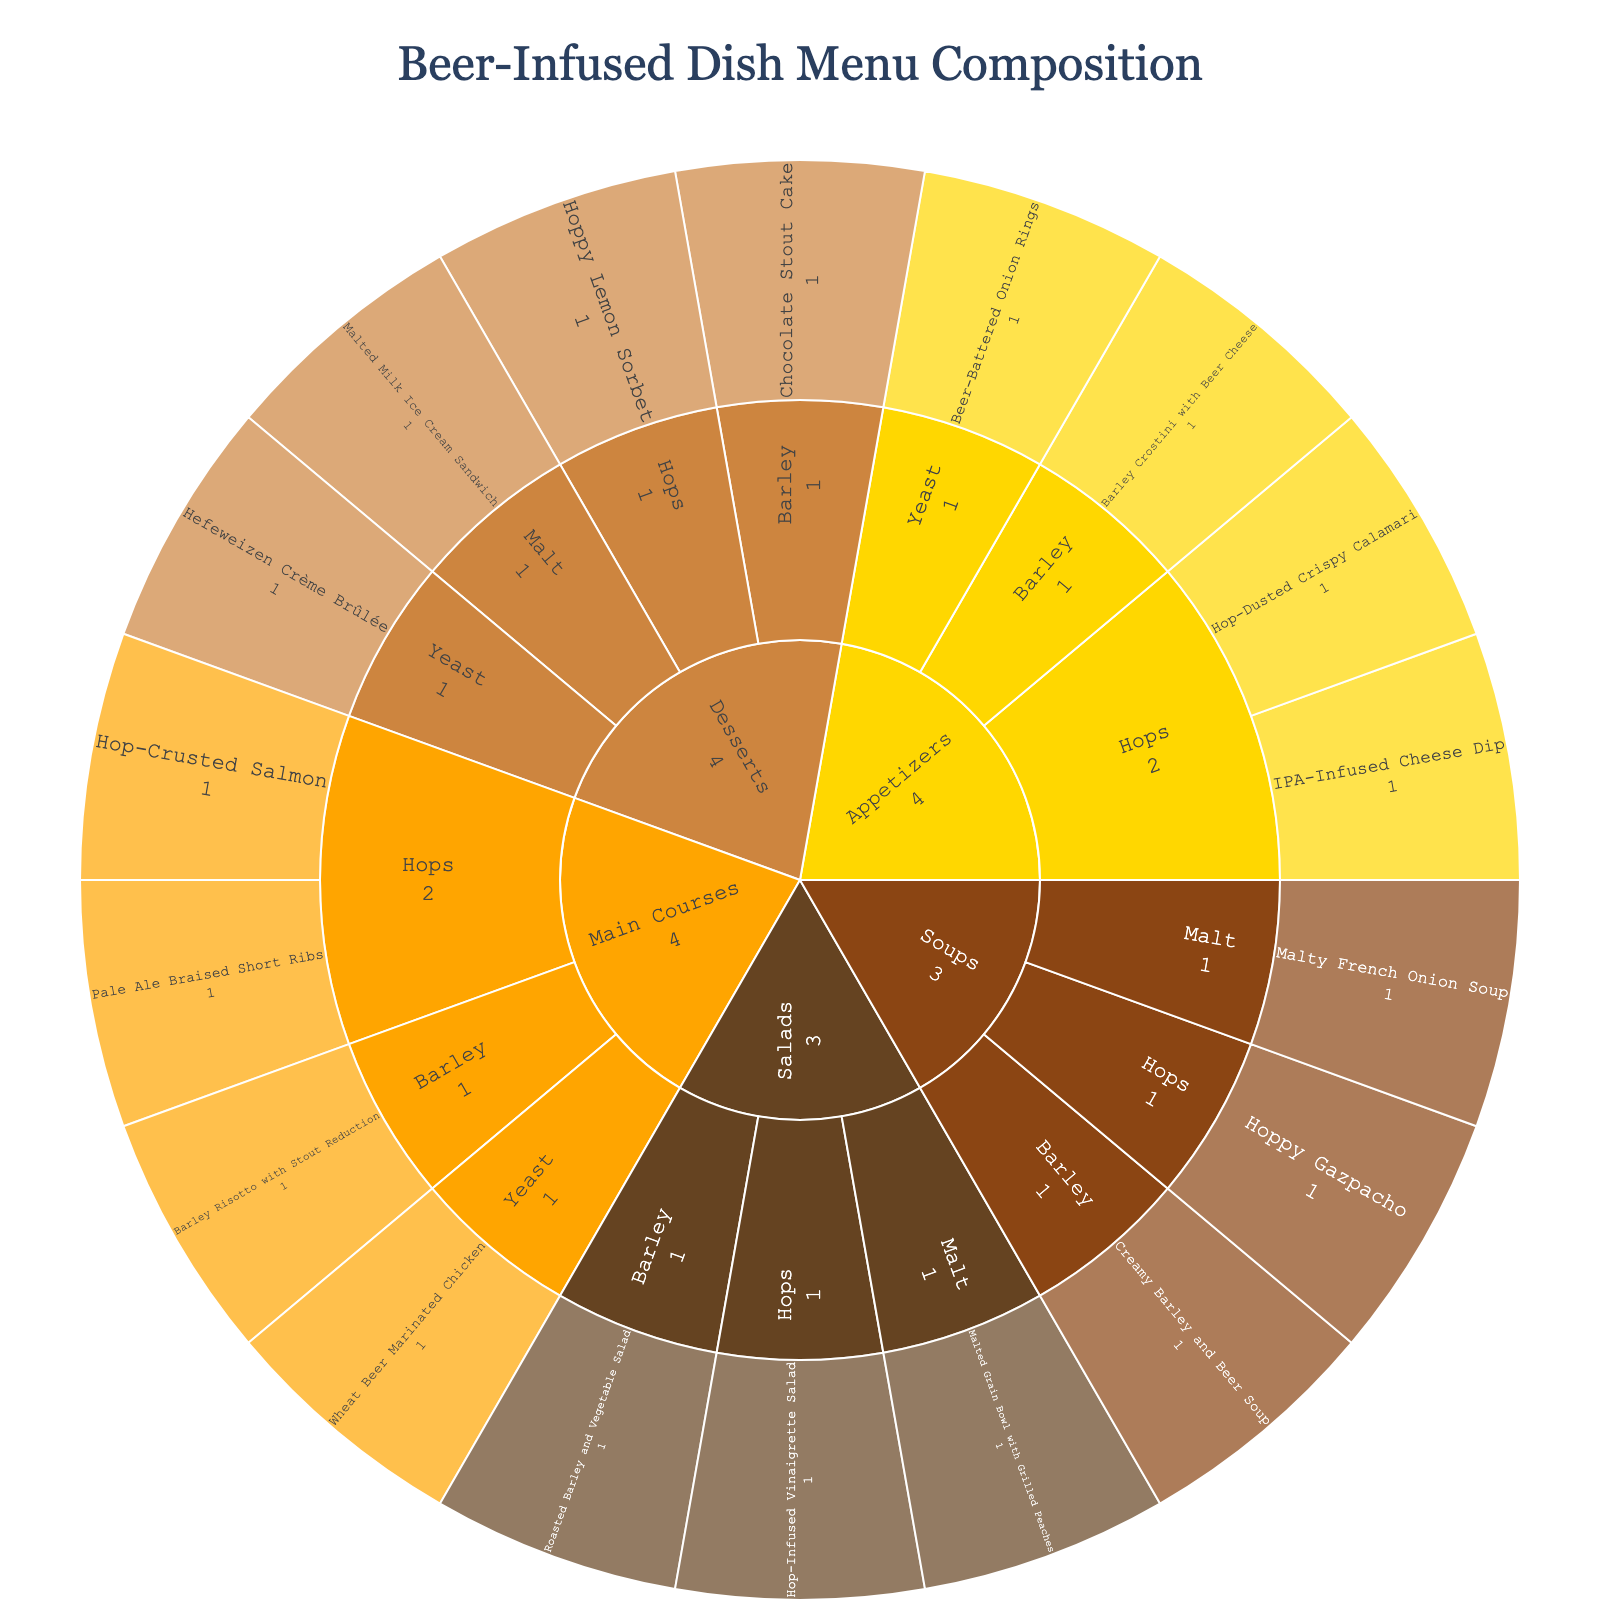Which course type has the most dishes? Count the segments for each course type. The "Appetizers" segment has the most dishes, with 4.
Answer: Appetizers How many dishes use hops as the primary beer ingredient? Count the segments under each course type where the primary beer ingredient is "Hops." Appetizers: 2, Main Courses: 2, Desserts: 1, Soups: 1, Salads: 1. Sum these counts (2+2+1+1+1).
Answer: 7 Which dessert uses yeast as the primary beer ingredient? Locate the "Desserts" segment and follow the path to "Yeast." The segment under yeast lists "Hefeweizen Crème Brûlée."
Answer: Hefeweizen Crème Brûlée Does the "Malt" beer ingredient appear more in soups or salads? Under "Soups," there is 1 dish with "Malt" (Malty French Onion Soup). Under "Salads," there is also 1 dish with "Malt" (Malted Grain Bowl with Grilled Peaches). Both have equal appearances.
Answer: Equal List all dishes that fall under the "Soups" course type. Follow the path under "Soups," which shows distinct beer ingredients and their associated dishes: Hops (Hoppy Gazpacho), Barley (Creamy Barley and Beer Soup), Malt (Malty French Onion Soup).
Answer: Hoppy Gazpacho, Creamy Barley and Beer Soup, Malty French Onion Soup Which course type has the fewest dishes using barley? Identify all course types and count the segments under "Barley:" Appetizers: 1, Main Courses: 1, Desserts: 1, Soups: 1, Salads: 1. All course types have equal count for "Barley."
Answer: Equal What's the most common beer ingredient in desserts? Locate the "Desserts" segment and count the segments for each beer ingredient. Hops: 1, Barley: 1, Yeast: 1, Malt: 1. All ingredients appear equally.
Answer: Equal How many unique beer ingredients are used in the menu? Identify the unique beer ingredient segments under all course types: Hops, Barley, Yeast, Malt. There are 4 unique beer ingredients used.
Answer: 4 Which appetizer dish uses barley as the primary beer ingredient? Locate the "Appetizers" segment and follow the path to "Barley." The segment lists "Barley Crostini with Beer Cheese."
Answer: Barley Crostini with Beer Cheese 